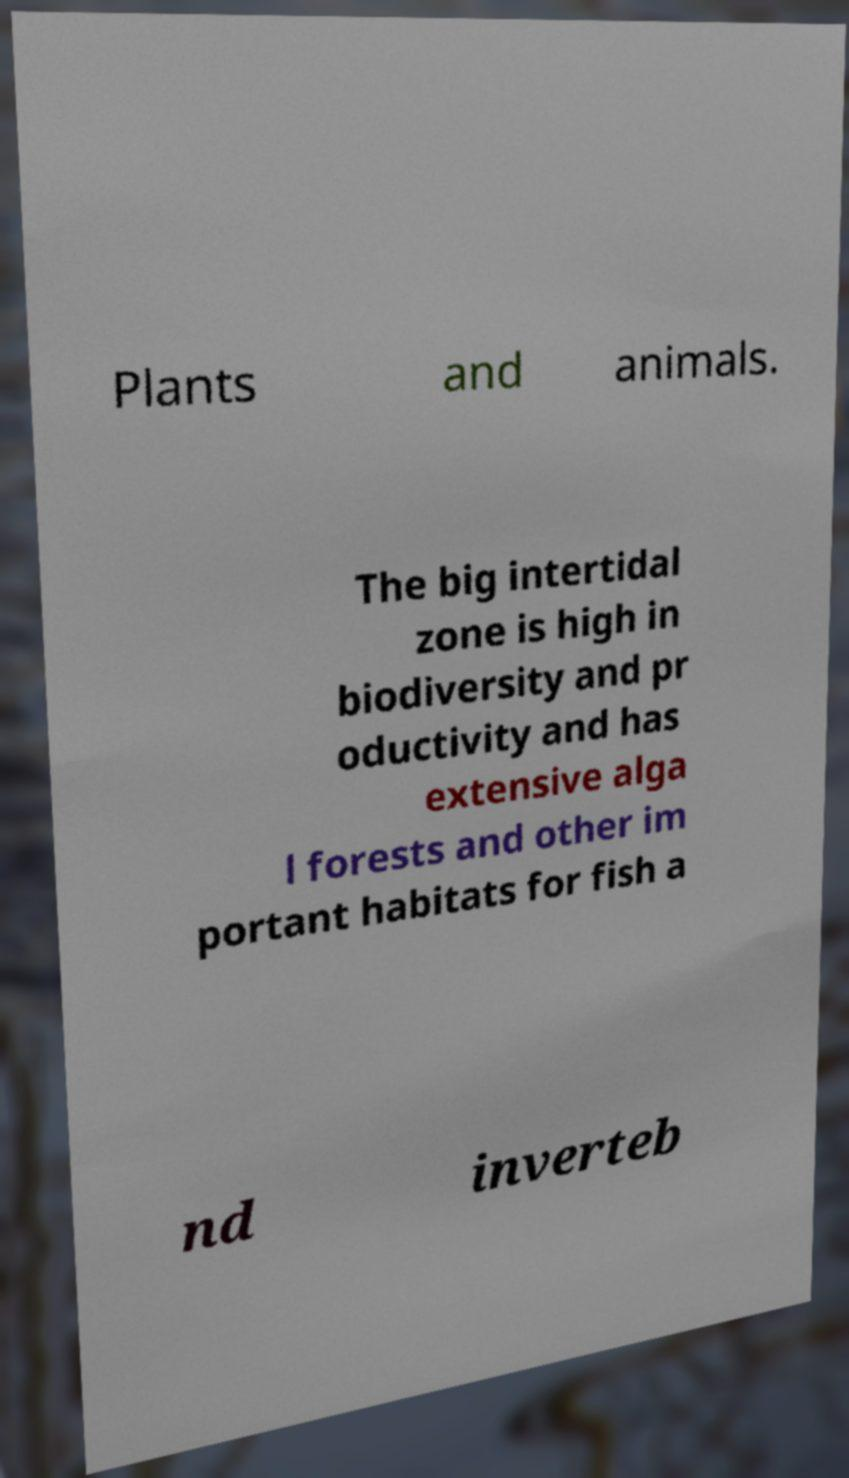What messages or text are displayed in this image? I need them in a readable, typed format. Plants and animals. The big intertidal zone is high in biodiversity and pr oductivity and has extensive alga l forests and other im portant habitats for fish a nd inverteb 